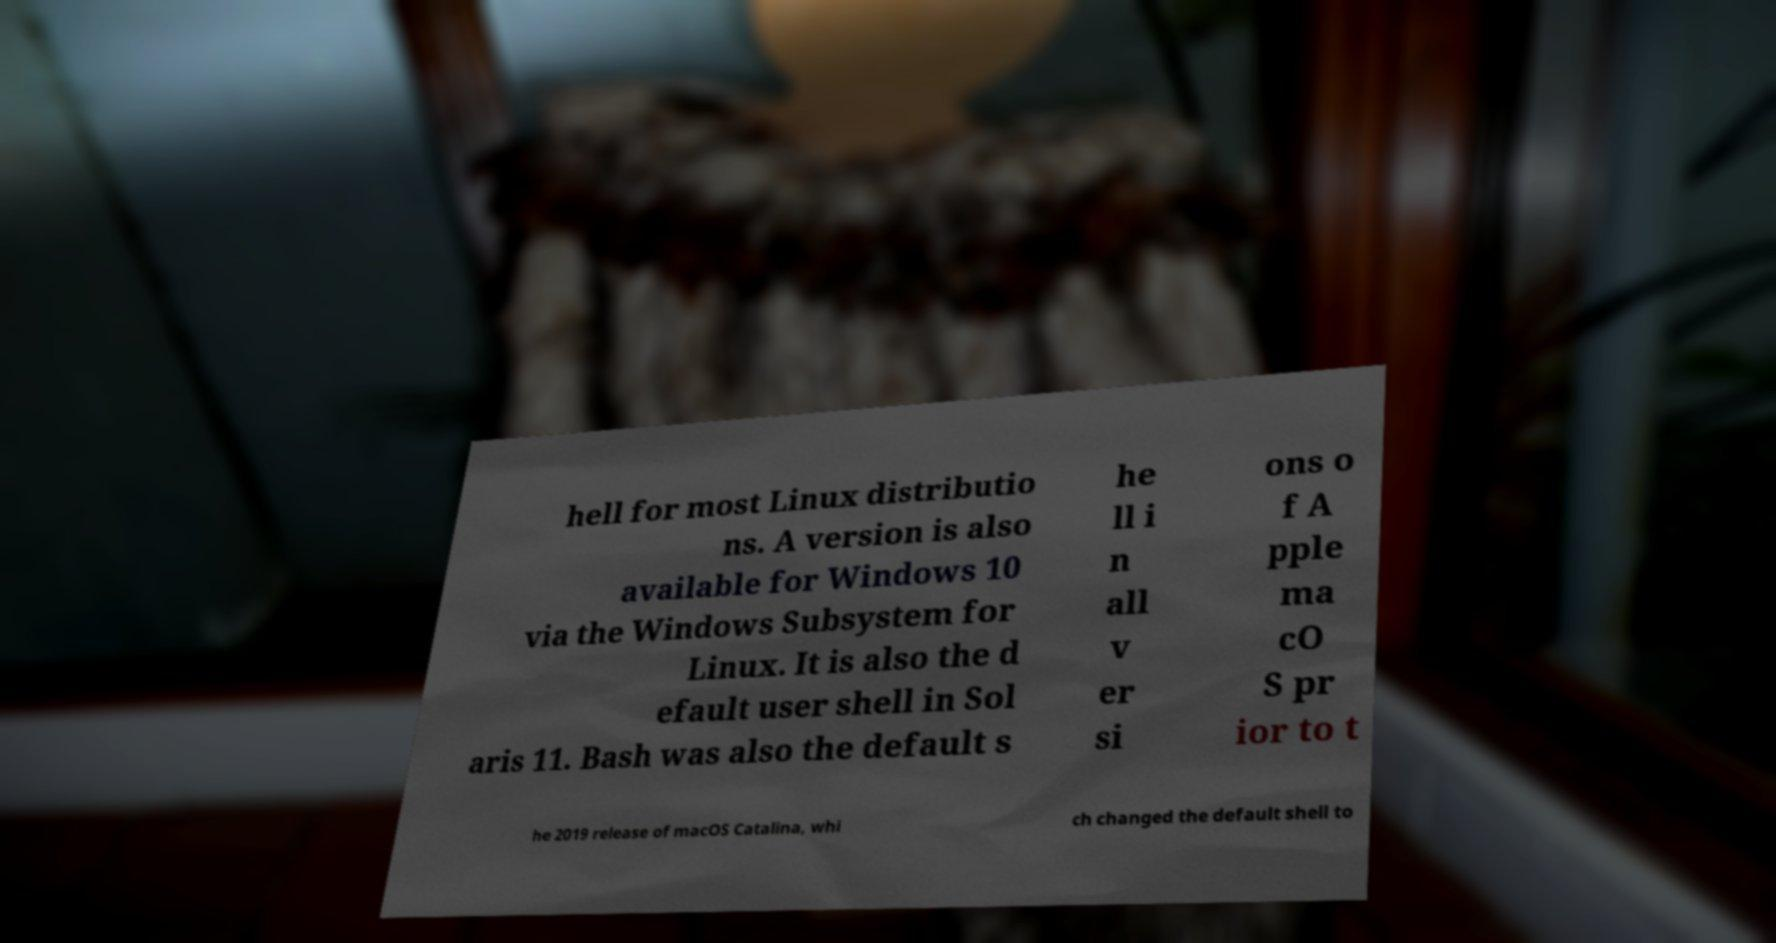Can you read and provide the text displayed in the image?This photo seems to have some interesting text. Can you extract and type it out for me? hell for most Linux distributio ns. A version is also available for Windows 10 via the Windows Subsystem for Linux. It is also the d efault user shell in Sol aris 11. Bash was also the default s he ll i n all v er si ons o f A pple ma cO S pr ior to t he 2019 release of macOS Catalina, whi ch changed the default shell to 